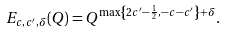Convert formula to latex. <formula><loc_0><loc_0><loc_500><loc_500>E _ { c , c ^ { \prime } , \delta } ( Q ) = Q ^ { \max \left \{ 2 c ^ { \prime } - \frac { 1 } { 2 } , - c - c ^ { \prime } \right \} + \delta } .</formula> 